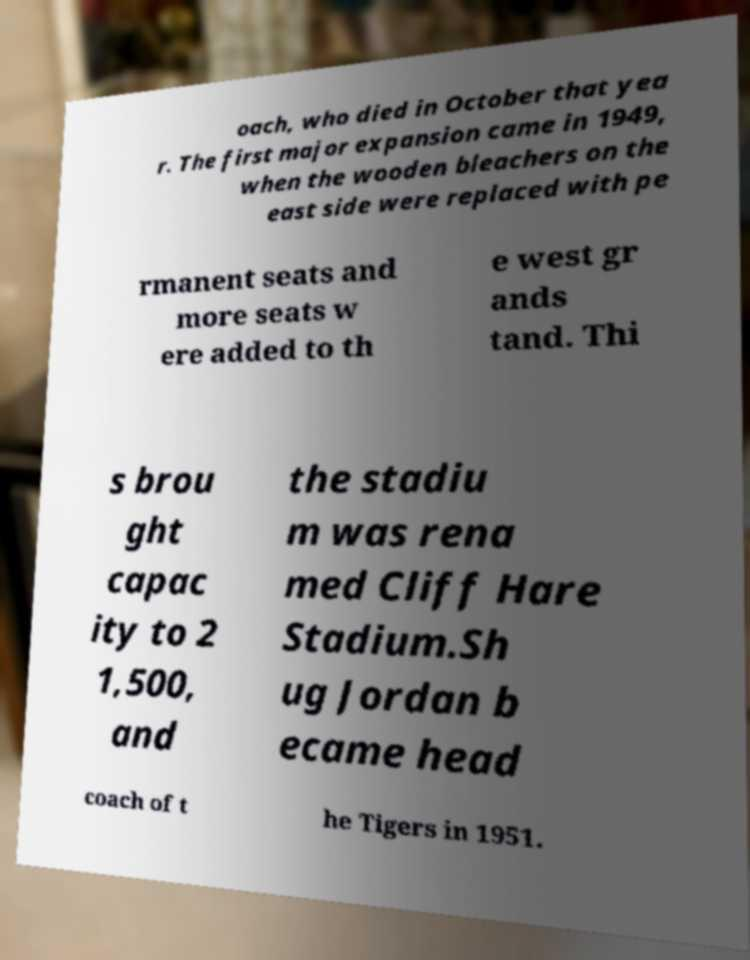Please read and relay the text visible in this image. What does it say? oach, who died in October that yea r. The first major expansion came in 1949, when the wooden bleachers on the east side were replaced with pe rmanent seats and more seats w ere added to th e west gr ands tand. Thi s brou ght capac ity to 2 1,500, and the stadiu m was rena med Cliff Hare Stadium.Sh ug Jordan b ecame head coach of t he Tigers in 1951. 